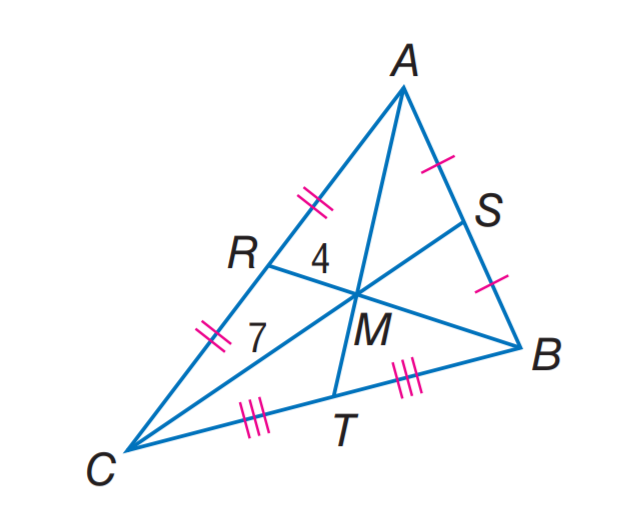Answer the mathemtical geometry problem and directly provide the correct option letter.
Question: M C = 7, R M = 4, and A T = 16. Find R B.
Choices: A: 6 B: 8 C: 12 D: 15 C 